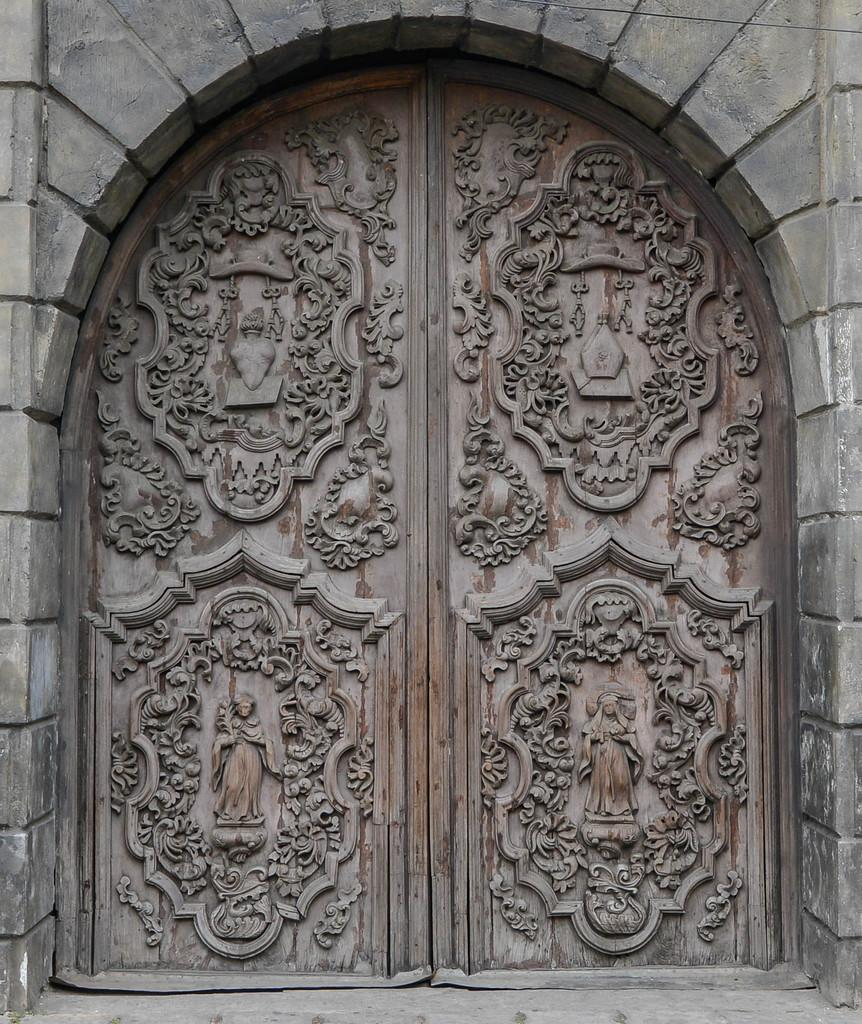What can be seen on the door in the image? There are carvings on the door in the image. What architectural feature is present in the image? There is an arch in the image. Where is the playground located in the image? There is no playground present in the image. Can you describe the icicles hanging from the arch in the image? There are no icicles present in the image; the image does not depict any icy conditions. 